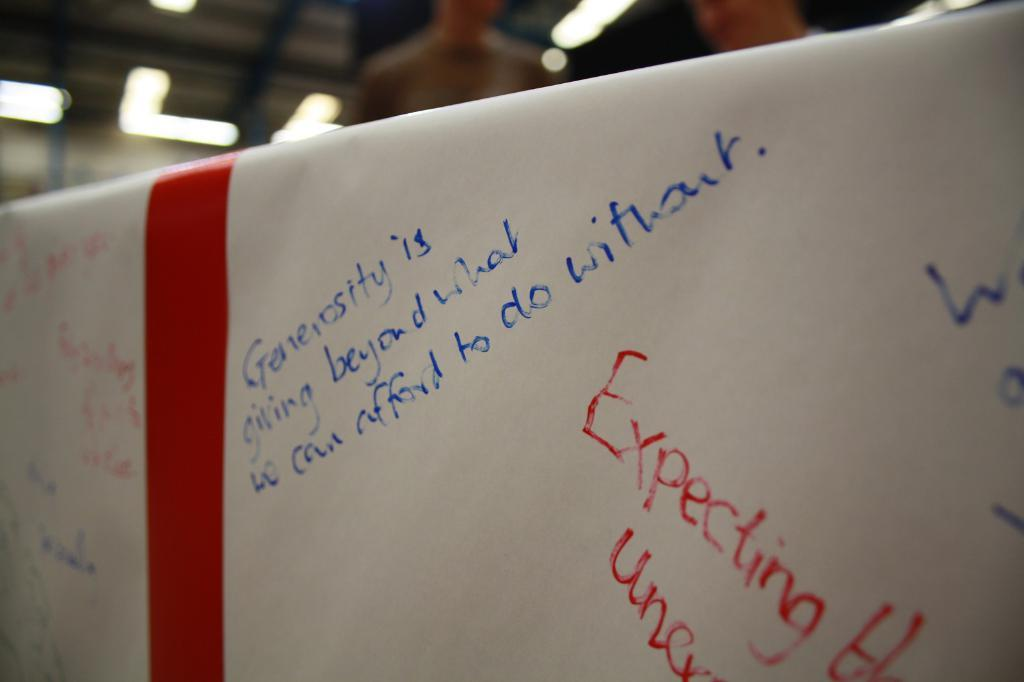<image>
Provide a brief description of the given image. Generosity is giving beyond and Expecting words wrote on a white poster. 